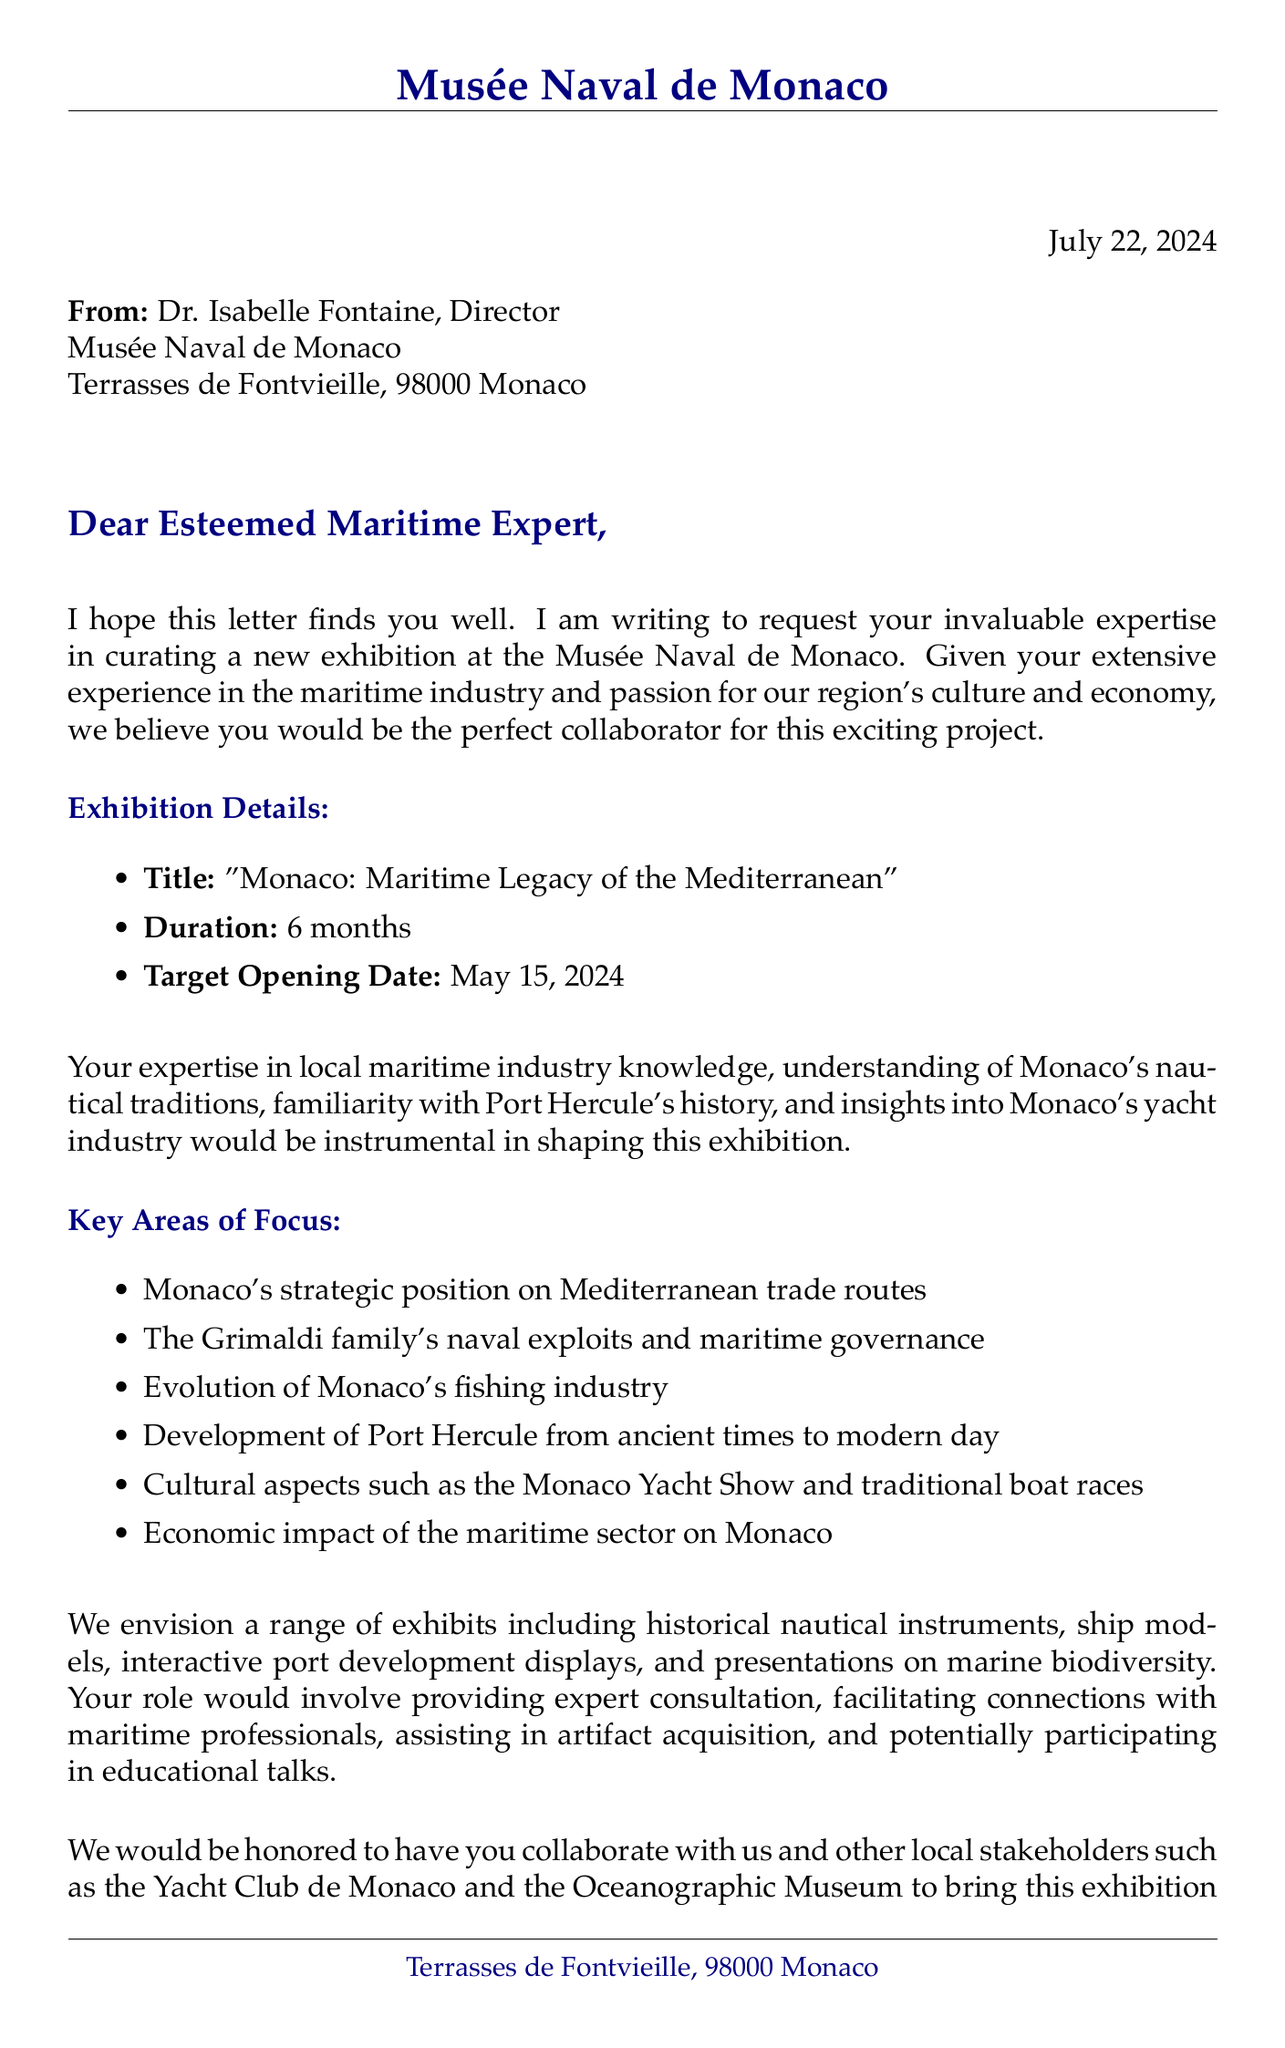What is the title of the exhibition? The title of the exhibition is listed in the document.
Answer: Monaco: Maritime Legacy of the Mediterranean Who is the director of the museum? The document specifies the name of the director.
Answer: Dr. Isabelle Fontaine When is the target opening date of the exhibition? The target opening date is clearly stated in the exhibition details.
Answer: May 15, 2024 What is one key area of focus mentioned for the exhibition? The document lists several key areas of focus for curation.
Answer: Monaco's strategic position on Mediterranean trade routes What type of exhibits are envisioned for the exhibition? The document outlines a variety of exhibits planned for display.
Answer: Historical nautical instruments and maps What role is expected from the maritime expert in the exhibition? The document details the responsibilities expected from the expert.
Answer: Providing expert consultation on exhibit content Which local stakeholders are mentioned in the letter? The document lists local stakeholders involved in the exhibition.
Answer: Yacht Club de Monaco How long will the exhibition last? The duration of the exhibition is provided in the document.
Answer: 6 months What is a cultural aspect highlighted in the letter? The document mentions cultural aspects related to Monaco's maritime heritage.
Answer: Annual Monaco Yacht Show 